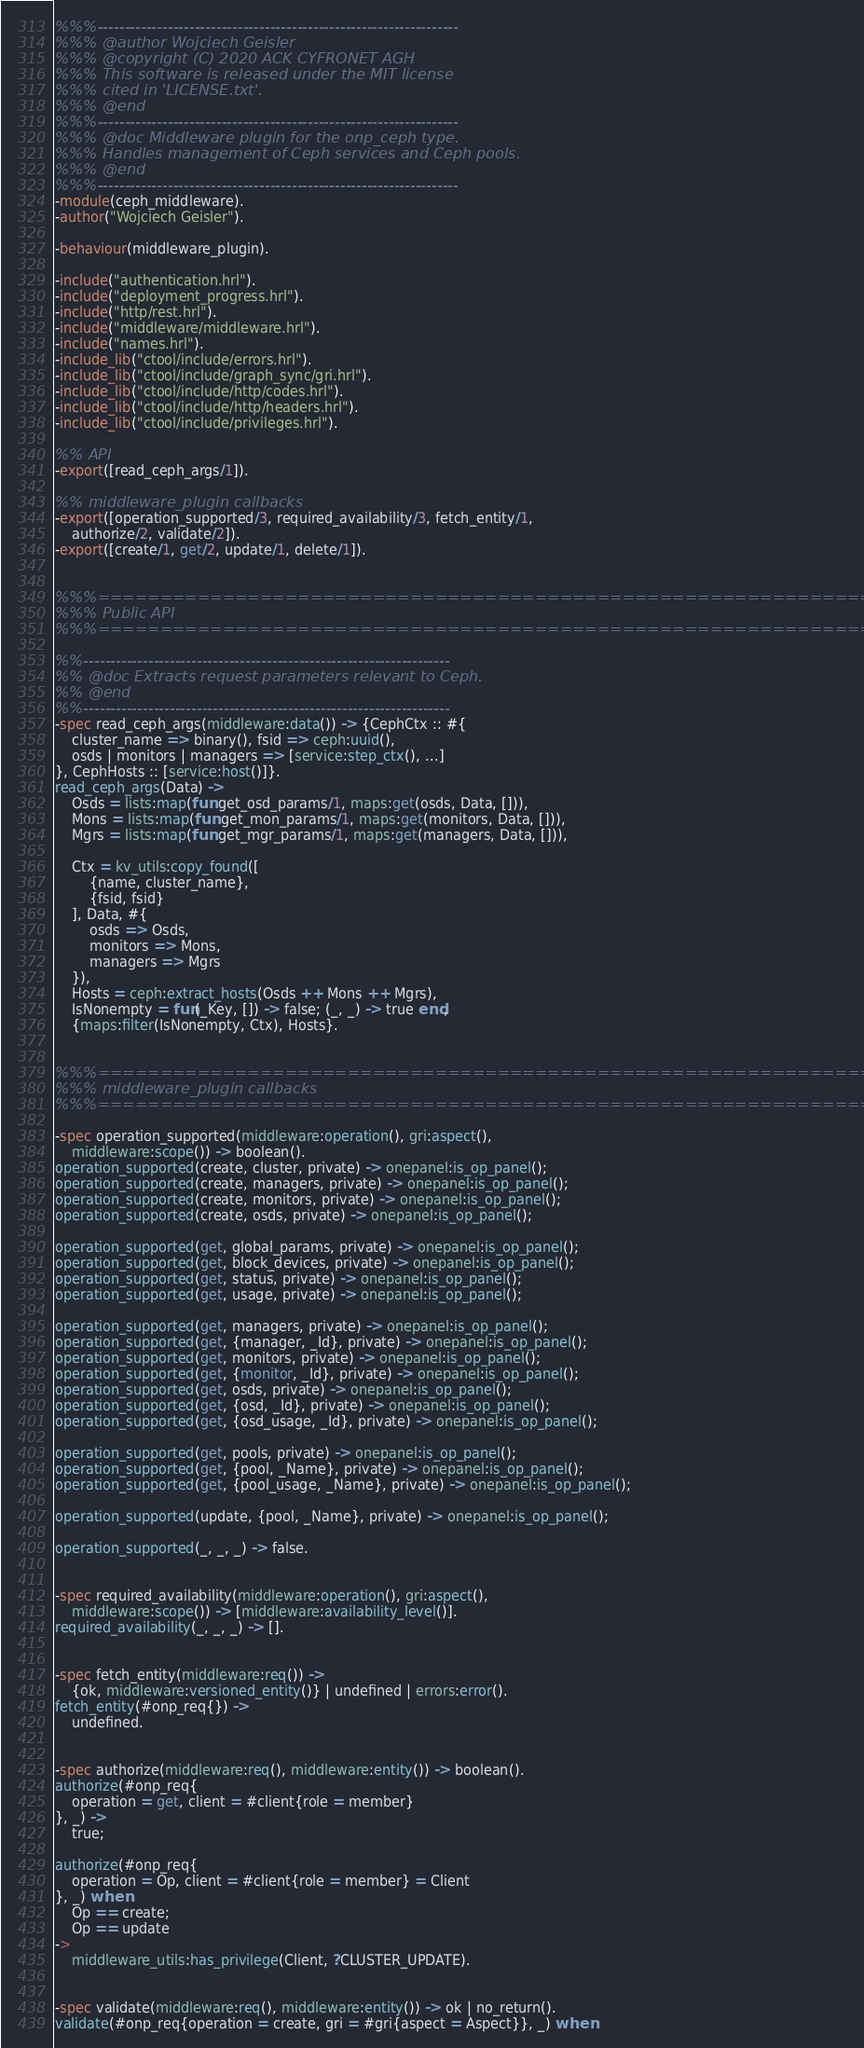Convert code to text. <code><loc_0><loc_0><loc_500><loc_500><_Erlang_>%%%-------------------------------------------------------------------
%%% @author Wojciech Geisler
%%% @copyright (C) 2020 ACK CYFRONET AGH
%%% This software is released under the MIT license
%%% cited in 'LICENSE.txt'.
%%% @end
%%%-------------------------------------------------------------------
%%% @doc Middleware plugin for the onp_ceph type.
%%% Handles management of Ceph services and Ceph pools.
%%% @end
%%%-------------------------------------------------------------------
-module(ceph_middleware).
-author("Wojciech Geisler").

-behaviour(middleware_plugin).

-include("authentication.hrl").
-include("deployment_progress.hrl").
-include("http/rest.hrl").
-include("middleware/middleware.hrl").
-include("names.hrl").
-include_lib("ctool/include/errors.hrl").
-include_lib("ctool/include/graph_sync/gri.hrl").
-include_lib("ctool/include/http/codes.hrl").
-include_lib("ctool/include/http/headers.hrl").
-include_lib("ctool/include/privileges.hrl").

%% API
-export([read_ceph_args/1]).

%% middleware_plugin callbacks
-export([operation_supported/3, required_availability/3, fetch_entity/1,
    authorize/2, validate/2]).
-export([create/1, get/2, update/1, delete/1]).


%%%===================================================================
%%% Public API
%%%===================================================================

%%--------------------------------------------------------------------
%% @doc Extracts request parameters relevant to Ceph.
%% @end
%%--------------------------------------------------------------------
-spec read_ceph_args(middleware:data()) -> {CephCtx :: #{
    cluster_name => binary(), fsid => ceph:uuid(),
    osds | monitors | managers => [service:step_ctx(), ...]
}, CephHosts :: [service:host()]}.
read_ceph_args(Data) ->
    Osds = lists:map(fun get_osd_params/1, maps:get(osds, Data, [])),
    Mons = lists:map(fun get_mon_params/1, maps:get(monitors, Data, [])),
    Mgrs = lists:map(fun get_mgr_params/1, maps:get(managers, Data, [])),

    Ctx = kv_utils:copy_found([
        {name, cluster_name},
        {fsid, fsid}
    ], Data, #{
        osds => Osds,
        monitors => Mons,
        managers => Mgrs
    }),
    Hosts = ceph:extract_hosts(Osds ++ Mons ++ Mgrs),
    IsNonempty = fun(_Key, []) -> false; (_, _) -> true end,
    {maps:filter(IsNonempty, Ctx), Hosts}.


%%%===================================================================
%%% middleware_plugin callbacks
%%%===================================================================

-spec operation_supported(middleware:operation(), gri:aspect(),
    middleware:scope()) -> boolean().
operation_supported(create, cluster, private) -> onepanel:is_op_panel();
operation_supported(create, managers, private) -> onepanel:is_op_panel();
operation_supported(create, monitors, private) -> onepanel:is_op_panel();
operation_supported(create, osds, private) -> onepanel:is_op_panel();

operation_supported(get, global_params, private) -> onepanel:is_op_panel();
operation_supported(get, block_devices, private) -> onepanel:is_op_panel();
operation_supported(get, status, private) -> onepanel:is_op_panel();
operation_supported(get, usage, private) -> onepanel:is_op_panel();

operation_supported(get, managers, private) -> onepanel:is_op_panel();
operation_supported(get, {manager, _Id}, private) -> onepanel:is_op_panel();
operation_supported(get, monitors, private) -> onepanel:is_op_panel();
operation_supported(get, {monitor, _Id}, private) -> onepanel:is_op_panel();
operation_supported(get, osds, private) -> onepanel:is_op_panel();
operation_supported(get, {osd, _Id}, private) -> onepanel:is_op_panel();
operation_supported(get, {osd_usage, _Id}, private) -> onepanel:is_op_panel();

operation_supported(get, pools, private) -> onepanel:is_op_panel();
operation_supported(get, {pool, _Name}, private) -> onepanel:is_op_panel();
operation_supported(get, {pool_usage, _Name}, private) -> onepanel:is_op_panel();

operation_supported(update, {pool, _Name}, private) -> onepanel:is_op_panel();

operation_supported(_, _, _) -> false.


-spec required_availability(middleware:operation(), gri:aspect(),
    middleware:scope()) -> [middleware:availability_level()].
required_availability(_, _, _) -> [].


-spec fetch_entity(middleware:req()) ->
    {ok, middleware:versioned_entity()} | undefined | errors:error().
fetch_entity(#onp_req{}) ->
    undefined.


-spec authorize(middleware:req(), middleware:entity()) -> boolean().
authorize(#onp_req{
    operation = get, client = #client{role = member}
}, _) ->
    true;

authorize(#onp_req{
    operation = Op, client = #client{role = member} = Client
}, _) when
    Op == create;
    Op == update
->
    middleware_utils:has_privilege(Client, ?CLUSTER_UPDATE).


-spec validate(middleware:req(), middleware:entity()) -> ok | no_return().
validate(#onp_req{operation = create, gri = #gri{aspect = Aspect}}, _) when</code> 